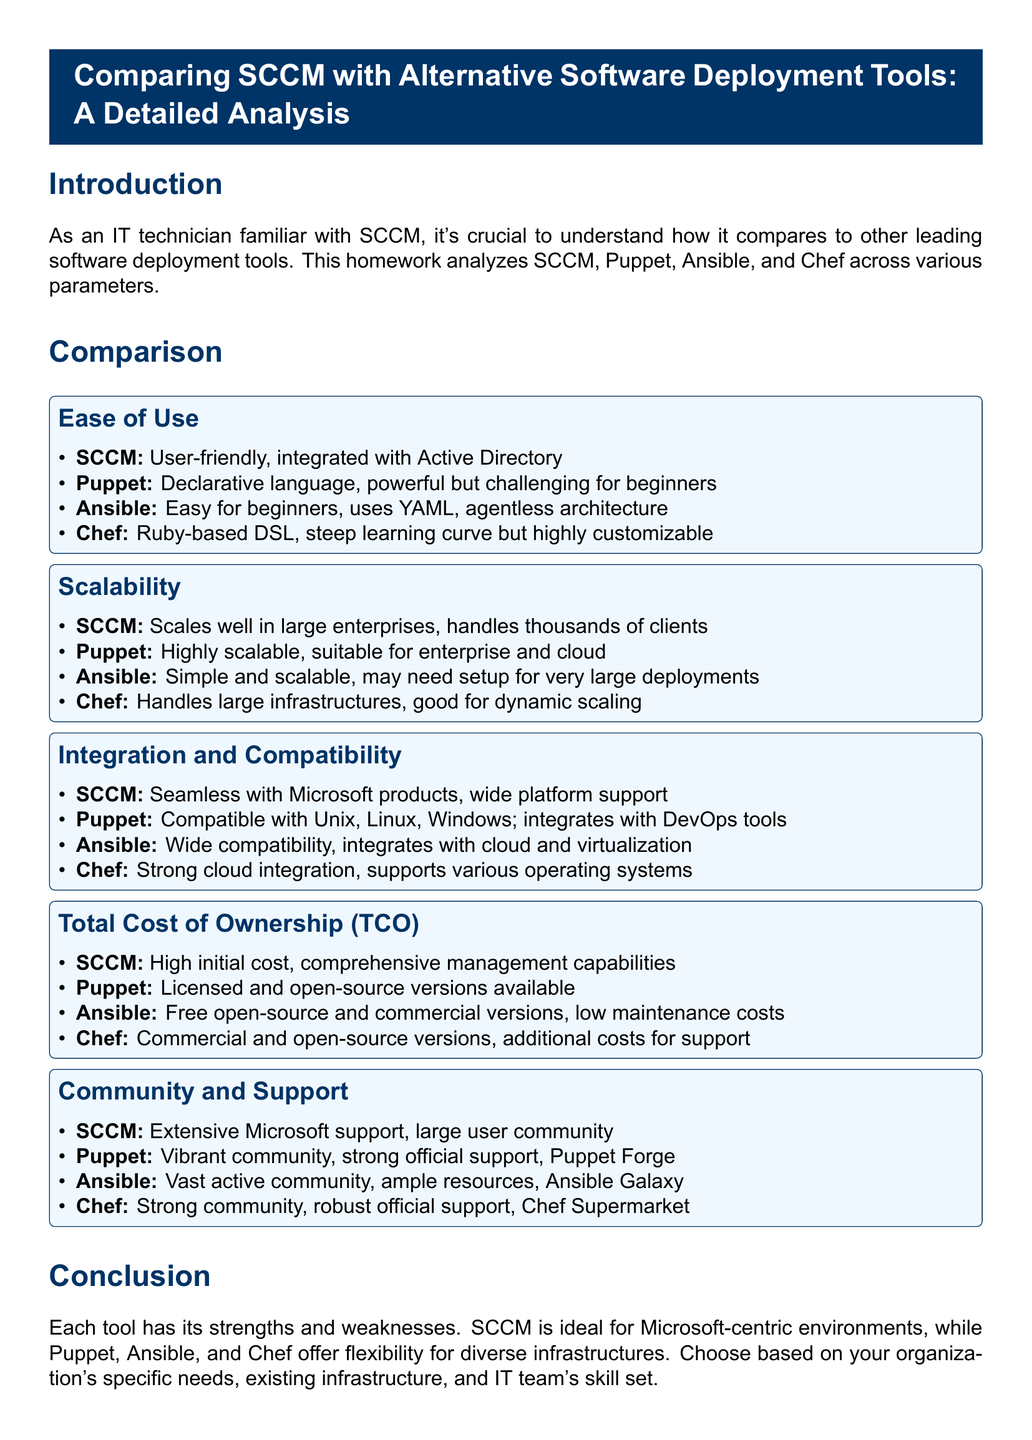What tool integrates seamlessly with Microsoft products? The document mentions that SCCM integrates seamlessly with Microsoft products and has wide platform support.
Answer: SCCM Which deployment tool uses a declarative language? Puppet is described as using a declarative language, which is powerful but challenging for beginners.
Answer: Puppet What is Ansible's architecture type? The document states that Ansible uses an agentless architecture, making it easy for beginners.
Answer: Agentless Which tool has a high initial cost according to the Total Cost of Ownership section? SCCM is indicated to have a high initial cost.
Answer: SCCM What is the main feature of Chef's programming language? The document describes Chef as using a Ruby-based DSL, indicating its programmability.
Answer: Ruby-based DSL Which alternative tool has robust official support and a strong community? The document mentions that Chef has robust official support and a strong community, specifically referencing Chef Supermarket.
Answer: Chef How do Puppet and Ansible differ in terms of scalability? Puppet is noted for being highly scalable and suitable for enterprise and cloud, while Ansible may need setup for very large deployments.
Answer: Scalability differences What type of support does SCCM have? The document states that SCCM has extensive Microsoft support and a large user community.
Answer: Extensive Microsoft support Which tool offers free open-source and commercial versions? Ansible is identified in the document as offering both free open-source and commercial versions, along with low maintenance costs.
Answer: Ansible 